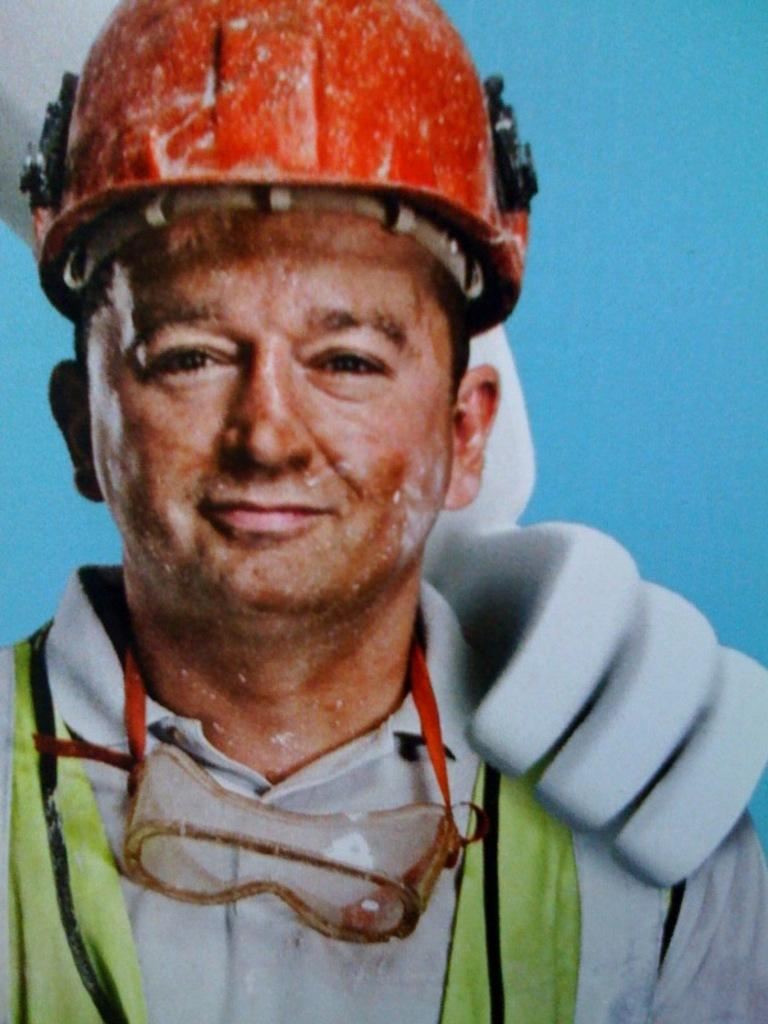What is the main subject of the picture? The main subject of the picture is an edited image of a man. Where is the man positioned in the image? The man is standing in the front. What is the man wearing on his head? The man is wearing a red helmet. What color is the background of the image? There is a blue background in the image. How many letters are visible on the calculator in the image? There is no calculator present in the image, so it is not possible to determine how many letters might be visible on it. 